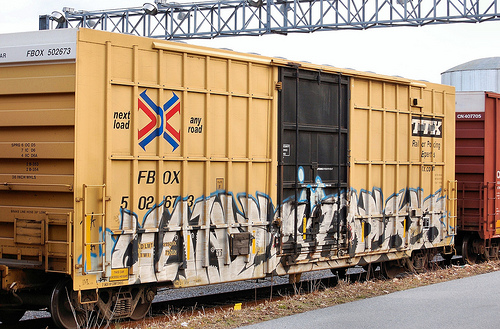<image>
Is there a silo behind the train? Yes. From this viewpoint, the silo is positioned behind the train, with the train partially or fully occluding the silo. 